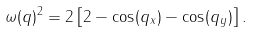<formula> <loc_0><loc_0><loc_500><loc_500>\omega ( { q } ) ^ { 2 } = 2 \left [ 2 - \cos ( q _ { x } ) - \cos ( q _ { y } ) \right ] .</formula> 